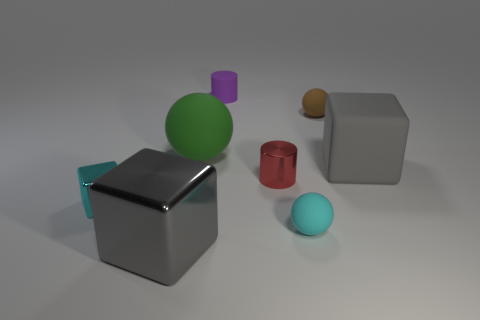How many things are either big yellow metal balls or rubber objects right of the purple matte cylinder?
Your response must be concise. 3. Are there more tiny cubes in front of the cyan rubber object than cyan metal cubes?
Your response must be concise. No. Is the number of purple cylinders that are in front of the tiny purple thing the same as the number of big green matte objects that are behind the green thing?
Your response must be concise. Yes. There is a large gray object that is right of the big green thing; are there any tiny rubber things that are in front of it?
Your answer should be compact. Yes. What is the shape of the purple rubber object?
Offer a terse response. Cylinder. What is the size of the other object that is the same color as the big shiny thing?
Offer a very short reply. Large. How big is the thing left of the gray thing that is to the left of the red thing?
Make the answer very short. Small. There is a cube that is right of the tiny purple rubber cylinder; how big is it?
Provide a succinct answer. Large. Are there fewer small shiny cylinders to the left of the red metal object than large green objects in front of the large gray matte thing?
Keep it short and to the point. No. What color is the shiny cylinder?
Your response must be concise. Red. 